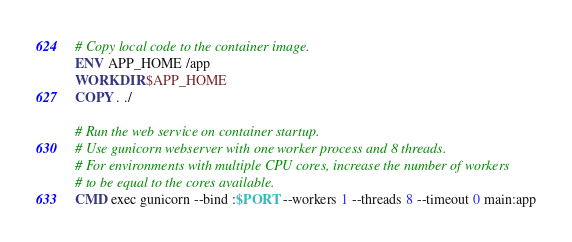<code> <loc_0><loc_0><loc_500><loc_500><_Dockerfile_>
# Copy local code to the container image.
ENV APP_HOME /app
WORKDIR $APP_HOME
COPY . ./

# Run the web service on container startup. 
# Use gunicorn webserver with one worker process and 8 threads.
# For environments with multiple CPU cores, increase the number of workers
# to be equal to the cores available.
CMD exec gunicorn --bind :$PORT --workers 1 --threads 8 --timeout 0 main:app
</code> 